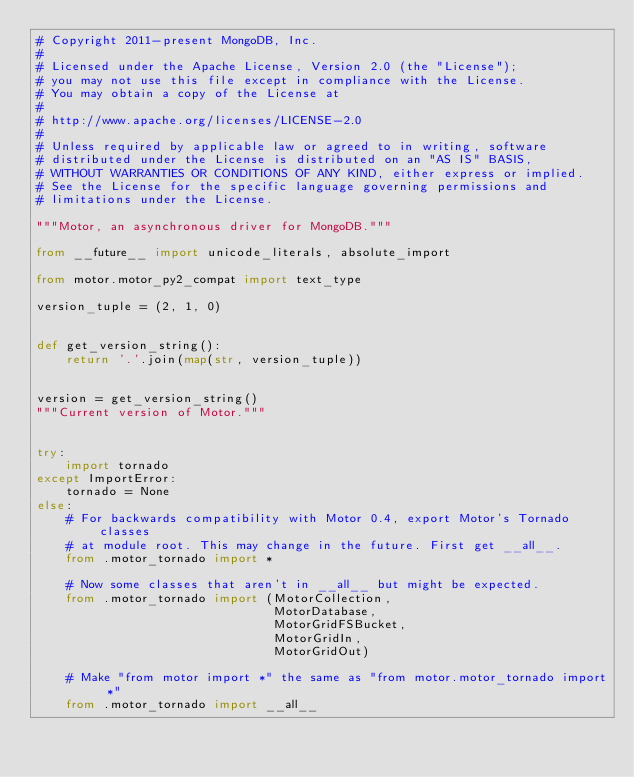Convert code to text. <code><loc_0><loc_0><loc_500><loc_500><_Python_># Copyright 2011-present MongoDB, Inc.
#
# Licensed under the Apache License, Version 2.0 (the "License");
# you may not use this file except in compliance with the License.
# You may obtain a copy of the License at
#
# http://www.apache.org/licenses/LICENSE-2.0
#
# Unless required by applicable law or agreed to in writing, software
# distributed under the License is distributed on an "AS IS" BASIS,
# WITHOUT WARRANTIES OR CONDITIONS OF ANY KIND, either express or implied.
# See the License for the specific language governing permissions and
# limitations under the License.

"""Motor, an asynchronous driver for MongoDB."""

from __future__ import unicode_literals, absolute_import

from motor.motor_py2_compat import text_type

version_tuple = (2, 1, 0)


def get_version_string():
    return '.'.join(map(str, version_tuple))


version = get_version_string()
"""Current version of Motor."""


try:
    import tornado
except ImportError:
    tornado = None
else:
    # For backwards compatibility with Motor 0.4, export Motor's Tornado classes
    # at module root. This may change in the future. First get __all__.
    from .motor_tornado import *

    # Now some classes that aren't in __all__ but might be expected.
    from .motor_tornado import (MotorCollection,
                                MotorDatabase,
                                MotorGridFSBucket,
                                MotorGridIn,
                                MotorGridOut)

    # Make "from motor import *" the same as "from motor.motor_tornado import *"
    from .motor_tornado import __all__
</code> 